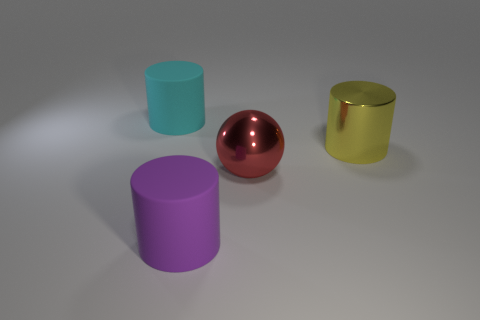Add 4 tiny gray metal objects. How many objects exist? 8 Subtract all yellow cylinders. How many cylinders are left? 2 Subtract all balls. How many objects are left? 3 Subtract 2 cylinders. How many cylinders are left? 1 Subtract all purple cylinders. How many cylinders are left? 2 Subtract 0 cyan cubes. How many objects are left? 4 Subtract all gray spheres. Subtract all red cubes. How many spheres are left? 1 Subtract all cyan objects. Subtract all rubber objects. How many objects are left? 1 Add 4 large cyan rubber cylinders. How many large cyan rubber cylinders are left? 5 Add 2 large green rubber balls. How many large green rubber balls exist? 2 